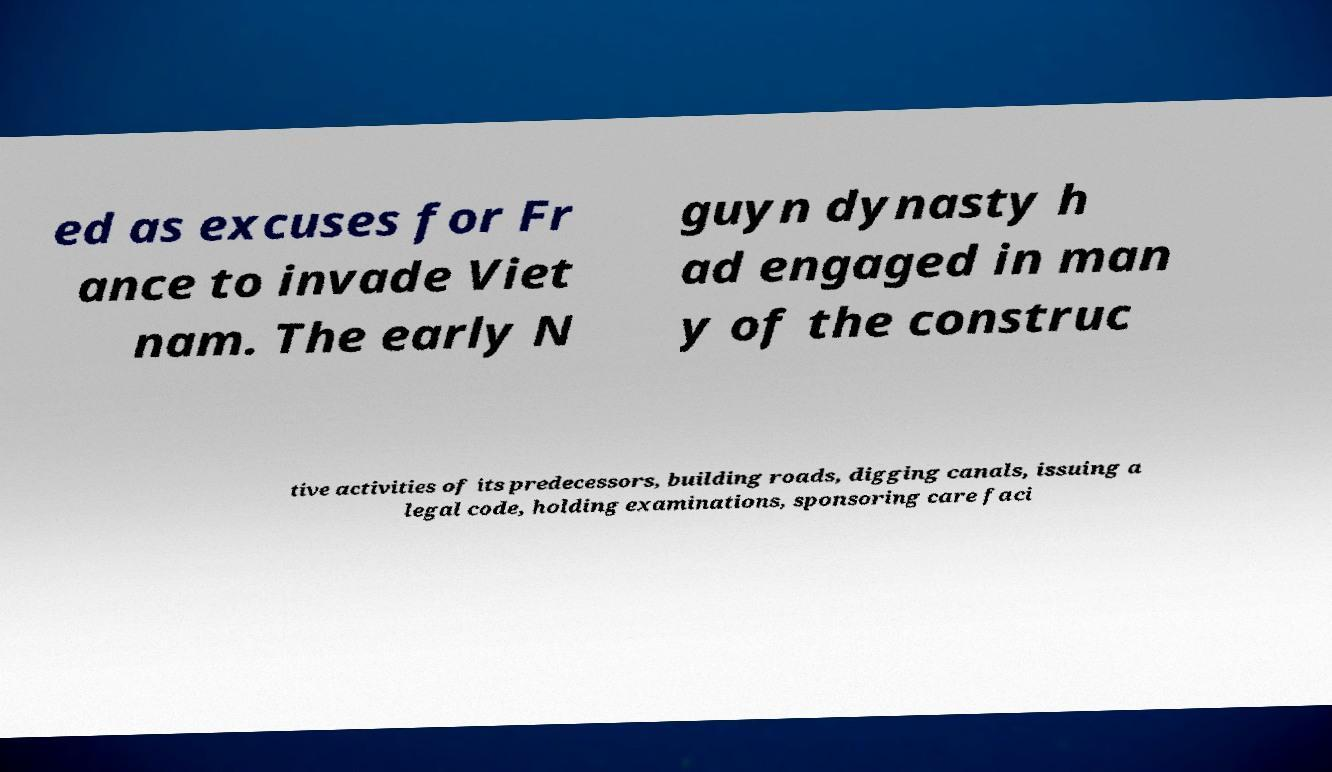Please identify and transcribe the text found in this image. ed as excuses for Fr ance to invade Viet nam. The early N guyn dynasty h ad engaged in man y of the construc tive activities of its predecessors, building roads, digging canals, issuing a legal code, holding examinations, sponsoring care faci 